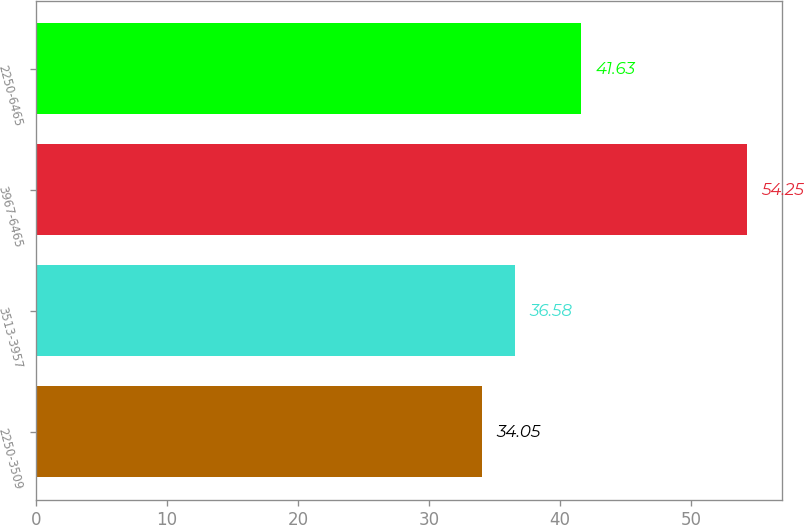Convert chart. <chart><loc_0><loc_0><loc_500><loc_500><bar_chart><fcel>2250-3509<fcel>3513-3957<fcel>3967-6465<fcel>2250-6465<nl><fcel>34.05<fcel>36.58<fcel>54.25<fcel>41.63<nl></chart> 